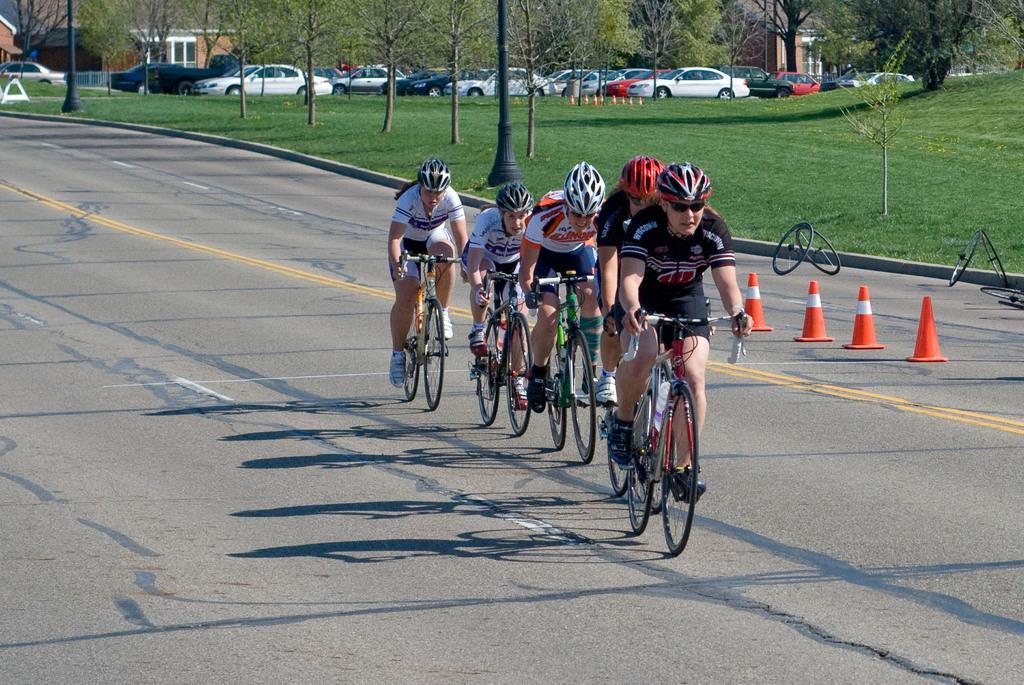How would you summarize this image in a sentence or two? There are people sitting and riding bicycles and wore helmets. We can see traffic cones and tires on the road and we can see grass. In the background we can see poles,trees,cars and houses. 